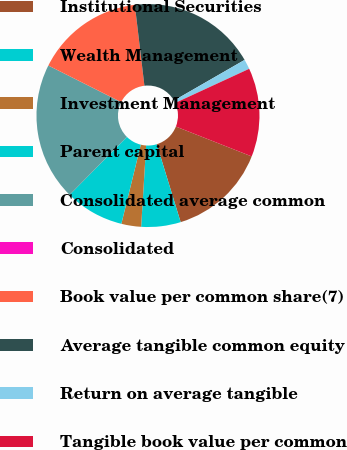<chart> <loc_0><loc_0><loc_500><loc_500><pie_chart><fcel>Institutional Securities<fcel>Wealth Management<fcel>Investment Management<fcel>Parent capital<fcel>Consolidated average common<fcel>Consolidated<fcel>Book value per common share(7)<fcel>Average tangible common equity<fcel>Return on average tangible<fcel>Tangible book value per common<nl><fcel>14.29%<fcel>5.71%<fcel>2.86%<fcel>8.57%<fcel>20.0%<fcel>0.0%<fcel>15.71%<fcel>18.57%<fcel>1.43%<fcel>12.86%<nl></chart> 